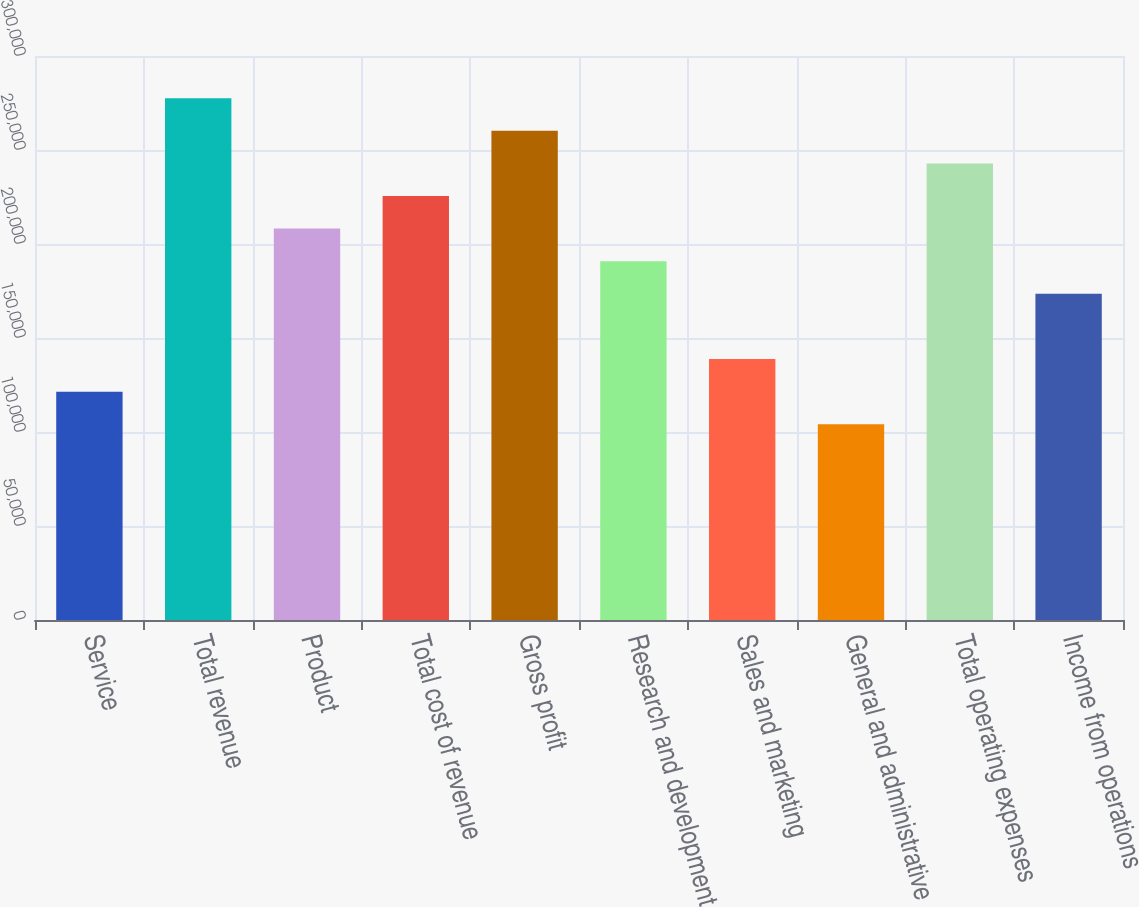Convert chart to OTSL. <chart><loc_0><loc_0><loc_500><loc_500><bar_chart><fcel>Service<fcel>Total revenue<fcel>Product<fcel>Total cost of revenue<fcel>Gross profit<fcel>Research and development<fcel>Sales and marketing<fcel>General and administrative<fcel>Total operating expenses<fcel>Income from operations<nl><fcel>121442<fcel>277582<fcel>208187<fcel>225536<fcel>260233<fcel>190838<fcel>138791<fcel>104094<fcel>242884<fcel>173489<nl></chart> 